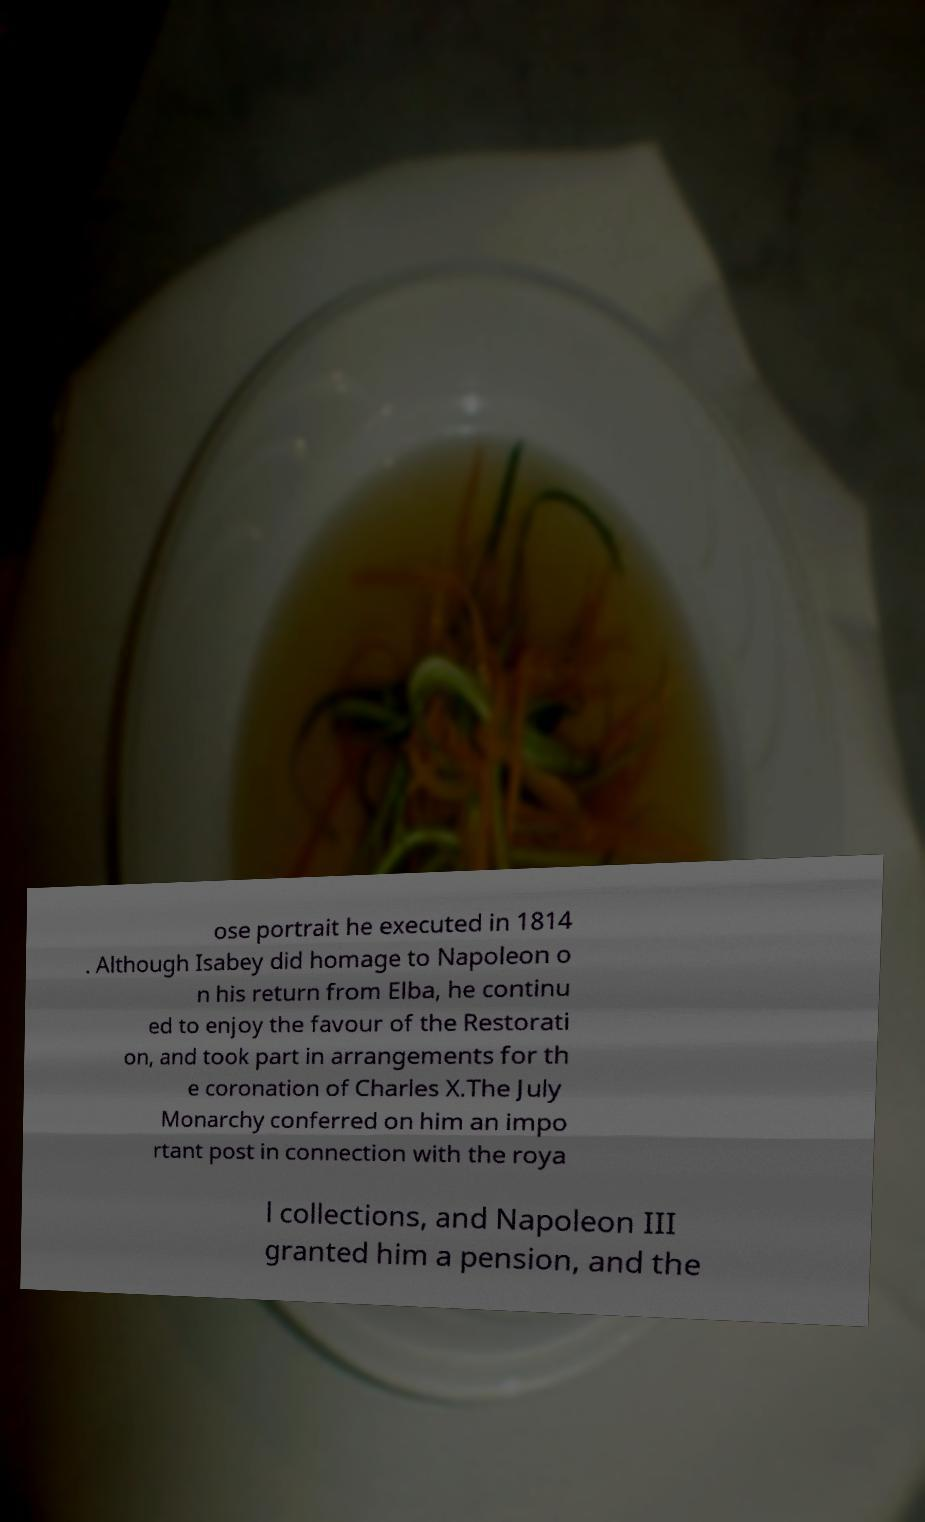Can you read and provide the text displayed in the image?This photo seems to have some interesting text. Can you extract and type it out for me? ose portrait he executed in 1814 . Although Isabey did homage to Napoleon o n his return from Elba, he continu ed to enjoy the favour of the Restorati on, and took part in arrangements for th e coronation of Charles X.The July Monarchy conferred on him an impo rtant post in connection with the roya l collections, and Napoleon III granted him a pension, and the 